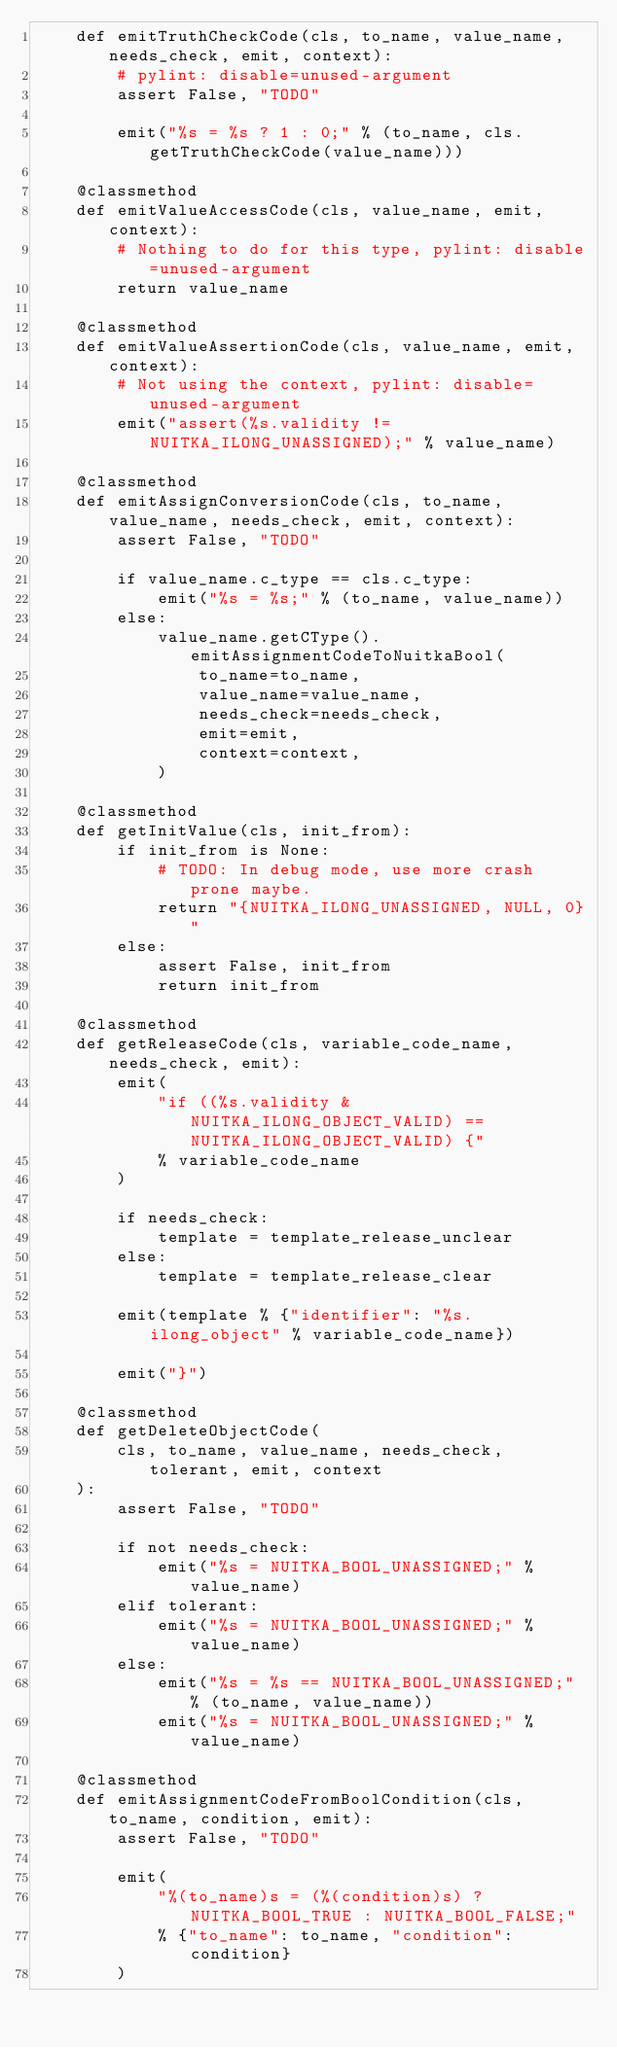<code> <loc_0><loc_0><loc_500><loc_500><_Python_>    def emitTruthCheckCode(cls, to_name, value_name, needs_check, emit, context):
        # pylint: disable=unused-argument
        assert False, "TODO"

        emit("%s = %s ? 1 : 0;" % (to_name, cls.getTruthCheckCode(value_name)))

    @classmethod
    def emitValueAccessCode(cls, value_name, emit, context):
        # Nothing to do for this type, pylint: disable=unused-argument
        return value_name

    @classmethod
    def emitValueAssertionCode(cls, value_name, emit, context):
        # Not using the context, pylint: disable=unused-argument
        emit("assert(%s.validity != NUITKA_ILONG_UNASSIGNED);" % value_name)

    @classmethod
    def emitAssignConversionCode(cls, to_name, value_name, needs_check, emit, context):
        assert False, "TODO"

        if value_name.c_type == cls.c_type:
            emit("%s = %s;" % (to_name, value_name))
        else:
            value_name.getCType().emitAssignmentCodeToNuitkaBool(
                to_name=to_name,
                value_name=value_name,
                needs_check=needs_check,
                emit=emit,
                context=context,
            )

    @classmethod
    def getInitValue(cls, init_from):
        if init_from is None:
            # TODO: In debug mode, use more crash prone maybe.
            return "{NUITKA_ILONG_UNASSIGNED, NULL, 0}"
        else:
            assert False, init_from
            return init_from

    @classmethod
    def getReleaseCode(cls, variable_code_name, needs_check, emit):
        emit(
            "if ((%s.validity & NUITKA_ILONG_OBJECT_VALID) == NUITKA_ILONG_OBJECT_VALID) {"
            % variable_code_name
        )

        if needs_check:
            template = template_release_unclear
        else:
            template = template_release_clear

        emit(template % {"identifier": "%s.ilong_object" % variable_code_name})

        emit("}")

    @classmethod
    def getDeleteObjectCode(
        cls, to_name, value_name, needs_check, tolerant, emit, context
    ):
        assert False, "TODO"

        if not needs_check:
            emit("%s = NUITKA_BOOL_UNASSIGNED;" % value_name)
        elif tolerant:
            emit("%s = NUITKA_BOOL_UNASSIGNED;" % value_name)
        else:
            emit("%s = %s == NUITKA_BOOL_UNASSIGNED;" % (to_name, value_name))
            emit("%s = NUITKA_BOOL_UNASSIGNED;" % value_name)

    @classmethod
    def emitAssignmentCodeFromBoolCondition(cls, to_name, condition, emit):
        assert False, "TODO"

        emit(
            "%(to_name)s = (%(condition)s) ? NUITKA_BOOL_TRUE : NUITKA_BOOL_FALSE;"
            % {"to_name": to_name, "condition": condition}
        )
</code> 